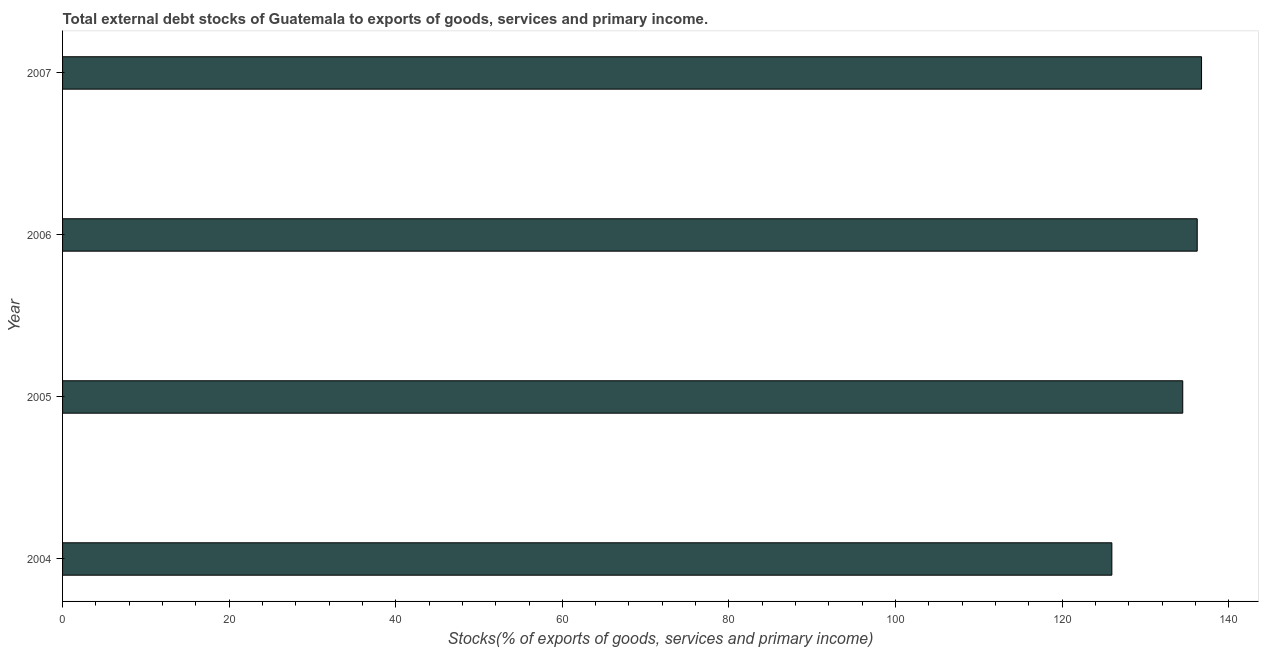Does the graph contain any zero values?
Provide a succinct answer. No. What is the title of the graph?
Keep it short and to the point. Total external debt stocks of Guatemala to exports of goods, services and primary income. What is the label or title of the X-axis?
Your answer should be very brief. Stocks(% of exports of goods, services and primary income). What is the label or title of the Y-axis?
Ensure brevity in your answer.  Year. What is the external debt stocks in 2007?
Provide a short and direct response. 136.74. Across all years, what is the maximum external debt stocks?
Provide a succinct answer. 136.74. Across all years, what is the minimum external debt stocks?
Offer a very short reply. 125.97. What is the sum of the external debt stocks?
Offer a very short reply. 533.42. What is the difference between the external debt stocks in 2004 and 2005?
Offer a very short reply. -8.51. What is the average external debt stocks per year?
Keep it short and to the point. 133.35. What is the median external debt stocks?
Keep it short and to the point. 135.35. Do a majority of the years between 2006 and 2007 (inclusive) have external debt stocks greater than 60 %?
Give a very brief answer. Yes. What is the ratio of the external debt stocks in 2004 to that in 2007?
Provide a succinct answer. 0.92. Is the external debt stocks in 2005 less than that in 2007?
Your answer should be compact. Yes. What is the difference between the highest and the second highest external debt stocks?
Offer a very short reply. 0.52. What is the difference between the highest and the lowest external debt stocks?
Provide a short and direct response. 10.77. In how many years, is the external debt stocks greater than the average external debt stocks taken over all years?
Give a very brief answer. 3. How many bars are there?
Make the answer very short. 4. Are all the bars in the graph horizontal?
Keep it short and to the point. Yes. How many years are there in the graph?
Your answer should be compact. 4. Are the values on the major ticks of X-axis written in scientific E-notation?
Give a very brief answer. No. What is the Stocks(% of exports of goods, services and primary income) in 2004?
Keep it short and to the point. 125.97. What is the Stocks(% of exports of goods, services and primary income) of 2005?
Offer a very short reply. 134.48. What is the Stocks(% of exports of goods, services and primary income) in 2006?
Your answer should be very brief. 136.22. What is the Stocks(% of exports of goods, services and primary income) in 2007?
Provide a short and direct response. 136.74. What is the difference between the Stocks(% of exports of goods, services and primary income) in 2004 and 2005?
Offer a terse response. -8.51. What is the difference between the Stocks(% of exports of goods, services and primary income) in 2004 and 2006?
Provide a succinct answer. -10.25. What is the difference between the Stocks(% of exports of goods, services and primary income) in 2004 and 2007?
Ensure brevity in your answer.  -10.77. What is the difference between the Stocks(% of exports of goods, services and primary income) in 2005 and 2006?
Offer a very short reply. -1.74. What is the difference between the Stocks(% of exports of goods, services and primary income) in 2005 and 2007?
Give a very brief answer. -2.26. What is the difference between the Stocks(% of exports of goods, services and primary income) in 2006 and 2007?
Ensure brevity in your answer.  -0.52. What is the ratio of the Stocks(% of exports of goods, services and primary income) in 2004 to that in 2005?
Your response must be concise. 0.94. What is the ratio of the Stocks(% of exports of goods, services and primary income) in 2004 to that in 2006?
Offer a very short reply. 0.93. What is the ratio of the Stocks(% of exports of goods, services and primary income) in 2004 to that in 2007?
Ensure brevity in your answer.  0.92. What is the ratio of the Stocks(% of exports of goods, services and primary income) in 2005 to that in 2007?
Your answer should be compact. 0.98. 